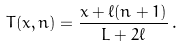<formula> <loc_0><loc_0><loc_500><loc_500>T ( x , n ) = \frac { x + \ell ( n + 1 ) } { L + 2 \ell } \, .</formula> 